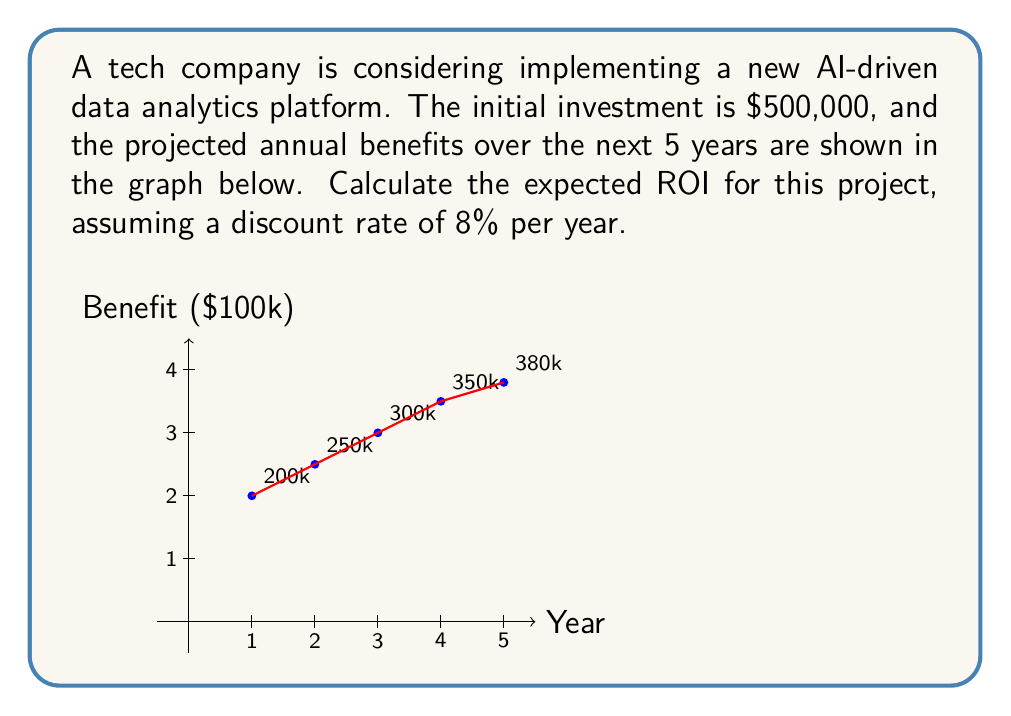Could you help me with this problem? To calculate the expected ROI, we need to follow these steps:

1) Calculate the Present Value (PV) of future benefits:
   Using the formula: $PV = \frac{FV}{(1+r)^n}$, where $r$ is the discount rate and $n$ is the year.

   Year 1: $PV_1 = \frac{200,000}{(1+0.08)^1} = 185,185.19$
   Year 2: $PV_2 = \frac{250,000}{(1+0.08)^2} = 214,334.71$
   Year 3: $PV_3 = \frac{300,000}{(1+0.08)^3} = 238,145.01$
   Year 4: $PV_4 = \frac{350,000}{(1+0.08)^4} = 257,009.61$
   Year 5: $PV_5 = \frac{380,000}{(1+0.08)^5} = 258,506.94$

2) Sum up all the present values:
   $\sum PV = 185,185.19 + 214,334.71 + 238,145.01 + 257,009.61 + 258,506.94 = 1,153,181.46$

3) Calculate the Net Present Value (NPV):
   $NPV = \sum PV - Initial Investment$
   $NPV = 1,153,181.46 - 500,000 = 653,181.46$

4) Calculate ROI:
   $ROI = \frac{NPV}{Initial Investment} \times 100\%$
   $ROI = \frac{653,181.46}{500,000} \times 100\% = 130.64\%$
Answer: 130.64% 